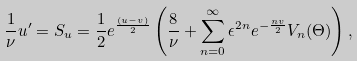<formula> <loc_0><loc_0><loc_500><loc_500>\frac { 1 } { \nu } u ^ { \prime } = S _ { u } = \frac { 1 } { 2 } e ^ { \frac { ( u - v ) } { 2 } } \left ( \frac { 8 } { \nu } + \sum _ { n = 0 } ^ { \infty } \epsilon ^ { 2 n } e ^ { - \frac { n v } { 2 } } V _ { n } ( \Theta ) \right ) ,</formula> 